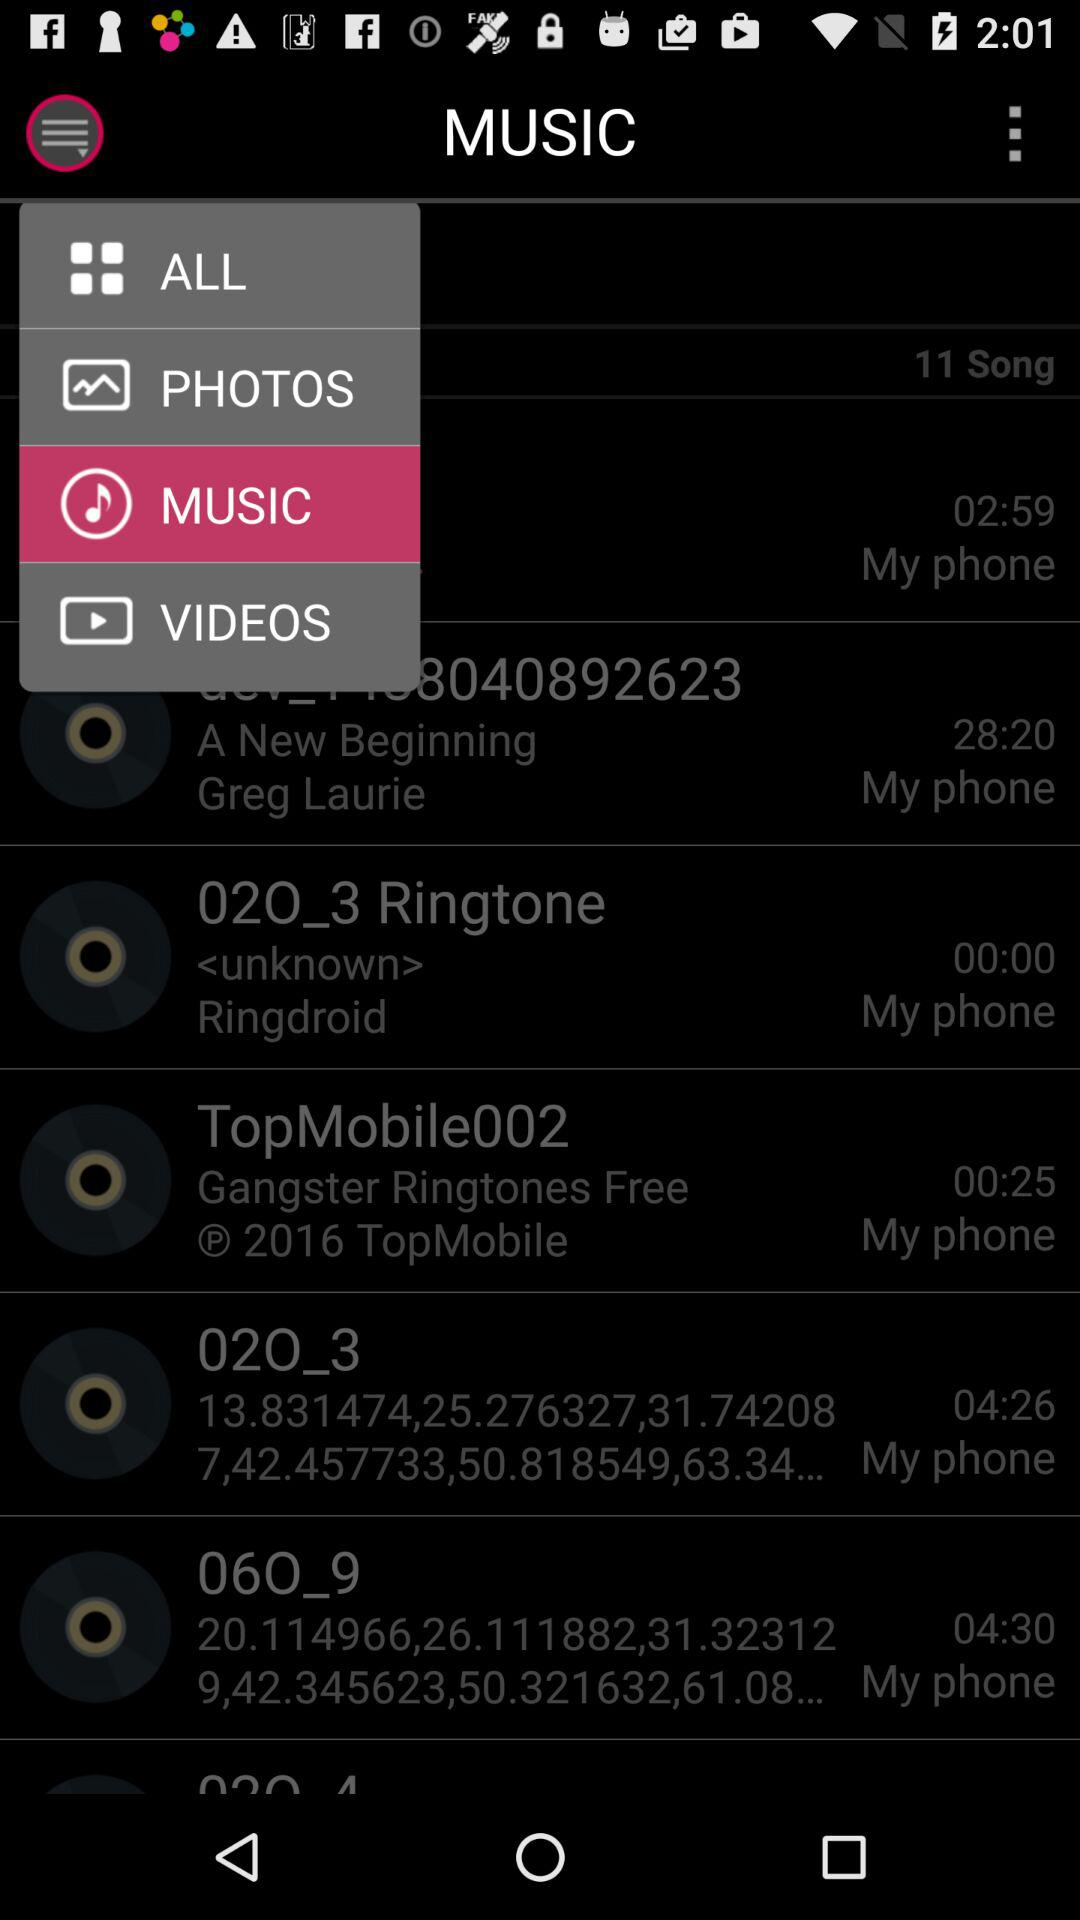Which song has the longest duration?
When the provided information is insufficient, respond with <no answer>. <no answer> 